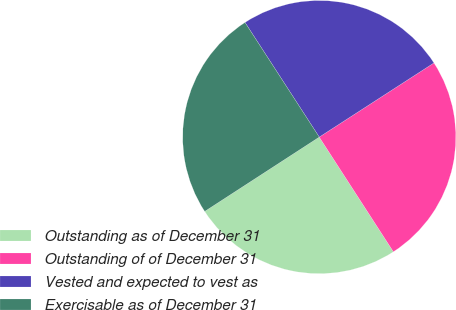Convert chart to OTSL. <chart><loc_0><loc_0><loc_500><loc_500><pie_chart><fcel>Outstanding as of December 31<fcel>Outstanding of of December 31<fcel>Vested and expected to vest as<fcel>Exercisable as of December 31<nl><fcel>24.97%<fcel>25.0%<fcel>25.01%<fcel>25.01%<nl></chart> 